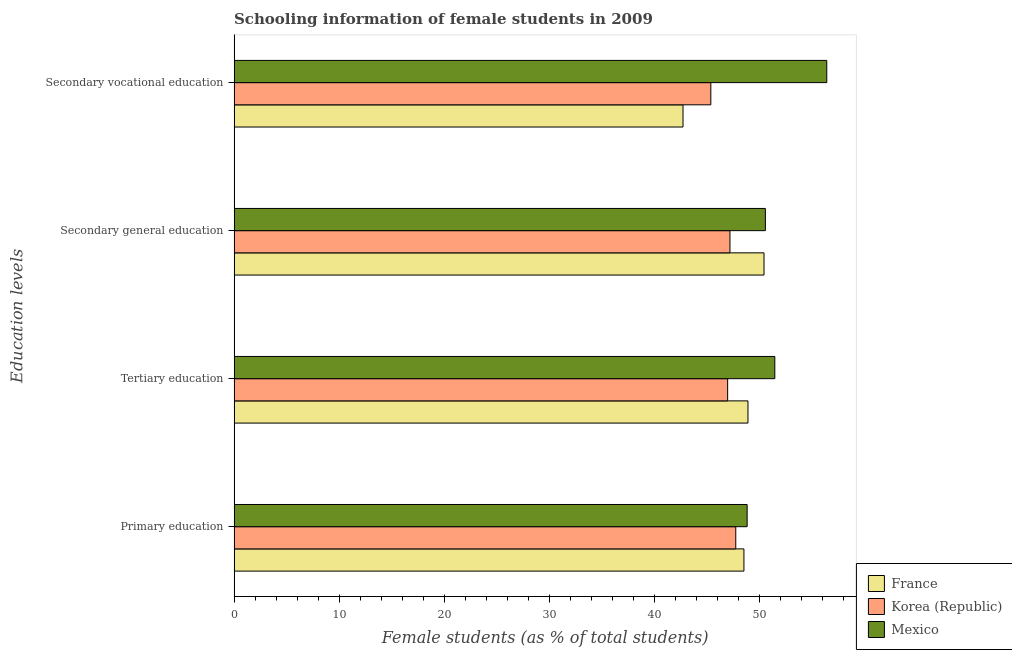How many different coloured bars are there?
Your response must be concise. 3. Are the number of bars per tick equal to the number of legend labels?
Ensure brevity in your answer.  Yes. Are the number of bars on each tick of the Y-axis equal?
Your response must be concise. Yes. How many bars are there on the 2nd tick from the bottom?
Give a very brief answer. 3. What is the label of the 2nd group of bars from the top?
Offer a very short reply. Secondary general education. What is the percentage of female students in tertiary education in France?
Your answer should be very brief. 48.91. Across all countries, what is the maximum percentage of female students in tertiary education?
Keep it short and to the point. 51.46. Across all countries, what is the minimum percentage of female students in secondary education?
Provide a short and direct response. 47.2. What is the total percentage of female students in secondary education in the graph?
Offer a very short reply. 148.2. What is the difference between the percentage of female students in secondary vocational education in France and that in Korea (Republic)?
Make the answer very short. -2.65. What is the difference between the percentage of female students in tertiary education in Korea (Republic) and the percentage of female students in primary education in France?
Your response must be concise. -1.55. What is the average percentage of female students in secondary education per country?
Give a very brief answer. 49.4. What is the difference between the percentage of female students in secondary vocational education and percentage of female students in primary education in Mexico?
Provide a succinct answer. 7.58. What is the ratio of the percentage of female students in tertiary education in Korea (Republic) to that in France?
Your response must be concise. 0.96. What is the difference between the highest and the second highest percentage of female students in secondary education?
Your answer should be very brief. 0.13. What is the difference between the highest and the lowest percentage of female students in secondary vocational education?
Provide a short and direct response. 13.68. In how many countries, is the percentage of female students in secondary vocational education greater than the average percentage of female students in secondary vocational education taken over all countries?
Offer a very short reply. 1. Is it the case that in every country, the sum of the percentage of female students in primary education and percentage of female students in tertiary education is greater than the sum of percentage of female students in secondary vocational education and percentage of female students in secondary education?
Your answer should be compact. No. What does the 3rd bar from the top in Primary education represents?
Make the answer very short. France. What does the 3rd bar from the bottom in Primary education represents?
Give a very brief answer. Mexico. Is it the case that in every country, the sum of the percentage of female students in primary education and percentage of female students in tertiary education is greater than the percentage of female students in secondary education?
Keep it short and to the point. Yes. How many bars are there?
Your answer should be compact. 12. What is the difference between two consecutive major ticks on the X-axis?
Give a very brief answer. 10. Are the values on the major ticks of X-axis written in scientific E-notation?
Your answer should be very brief. No. Does the graph contain grids?
Your response must be concise. No. Where does the legend appear in the graph?
Your response must be concise. Bottom right. How are the legend labels stacked?
Offer a terse response. Vertical. What is the title of the graph?
Ensure brevity in your answer.  Schooling information of female students in 2009. What is the label or title of the X-axis?
Your answer should be compact. Female students (as % of total students). What is the label or title of the Y-axis?
Provide a succinct answer. Education levels. What is the Female students (as % of total students) in France in Primary education?
Keep it short and to the point. 48.53. What is the Female students (as % of total students) of Korea (Republic) in Primary education?
Give a very brief answer. 47.75. What is the Female students (as % of total students) of Mexico in Primary education?
Your answer should be very brief. 48.83. What is the Female students (as % of total students) of France in Tertiary education?
Offer a terse response. 48.91. What is the Female students (as % of total students) of Korea (Republic) in Tertiary education?
Ensure brevity in your answer.  46.98. What is the Female students (as % of total students) in Mexico in Tertiary education?
Keep it short and to the point. 51.46. What is the Female students (as % of total students) of France in Secondary general education?
Your response must be concise. 50.44. What is the Female students (as % of total students) of Korea (Republic) in Secondary general education?
Your answer should be compact. 47.2. What is the Female students (as % of total students) in Mexico in Secondary general education?
Keep it short and to the point. 50.57. What is the Female students (as % of total students) in France in Secondary vocational education?
Your answer should be compact. 42.73. What is the Female students (as % of total students) in Korea (Republic) in Secondary vocational education?
Keep it short and to the point. 45.38. What is the Female students (as % of total students) of Mexico in Secondary vocational education?
Make the answer very short. 56.41. Across all Education levels, what is the maximum Female students (as % of total students) of France?
Provide a short and direct response. 50.44. Across all Education levels, what is the maximum Female students (as % of total students) of Korea (Republic)?
Provide a succinct answer. 47.75. Across all Education levels, what is the maximum Female students (as % of total students) in Mexico?
Ensure brevity in your answer.  56.41. Across all Education levels, what is the minimum Female students (as % of total students) in France?
Ensure brevity in your answer.  42.73. Across all Education levels, what is the minimum Female students (as % of total students) in Korea (Republic)?
Provide a succinct answer. 45.38. Across all Education levels, what is the minimum Female students (as % of total students) in Mexico?
Keep it short and to the point. 48.83. What is the total Female students (as % of total students) in France in the graph?
Provide a short and direct response. 190.6. What is the total Female students (as % of total students) in Korea (Republic) in the graph?
Offer a terse response. 187.3. What is the total Female students (as % of total students) in Mexico in the graph?
Give a very brief answer. 207.27. What is the difference between the Female students (as % of total students) in France in Primary education and that in Tertiary education?
Provide a short and direct response. -0.38. What is the difference between the Female students (as % of total students) in Korea (Republic) in Primary education and that in Tertiary education?
Your answer should be compact. 0.77. What is the difference between the Female students (as % of total students) in Mexico in Primary education and that in Tertiary education?
Offer a very short reply. -2.63. What is the difference between the Female students (as % of total students) of France in Primary education and that in Secondary general education?
Your answer should be very brief. -1.91. What is the difference between the Female students (as % of total students) in Korea (Republic) in Primary education and that in Secondary general education?
Make the answer very short. 0.55. What is the difference between the Female students (as % of total students) of Mexico in Primary education and that in Secondary general education?
Ensure brevity in your answer.  -1.73. What is the difference between the Female students (as % of total students) in France in Primary education and that in Secondary vocational education?
Ensure brevity in your answer.  5.8. What is the difference between the Female students (as % of total students) of Korea (Republic) in Primary education and that in Secondary vocational education?
Provide a short and direct response. 2.37. What is the difference between the Female students (as % of total students) of Mexico in Primary education and that in Secondary vocational education?
Provide a short and direct response. -7.58. What is the difference between the Female students (as % of total students) of France in Tertiary education and that in Secondary general education?
Offer a very short reply. -1.53. What is the difference between the Female students (as % of total students) in Korea (Republic) in Tertiary education and that in Secondary general education?
Your answer should be compact. -0.22. What is the difference between the Female students (as % of total students) in Mexico in Tertiary education and that in Secondary general education?
Provide a short and direct response. 0.9. What is the difference between the Female students (as % of total students) in France in Tertiary education and that in Secondary vocational education?
Your response must be concise. 6.18. What is the difference between the Female students (as % of total students) of Mexico in Tertiary education and that in Secondary vocational education?
Provide a succinct answer. -4.95. What is the difference between the Female students (as % of total students) of France in Secondary general education and that in Secondary vocational education?
Provide a succinct answer. 7.71. What is the difference between the Female students (as % of total students) in Korea (Republic) in Secondary general education and that in Secondary vocational education?
Keep it short and to the point. 1.82. What is the difference between the Female students (as % of total students) in Mexico in Secondary general education and that in Secondary vocational education?
Your response must be concise. -5.84. What is the difference between the Female students (as % of total students) of France in Primary education and the Female students (as % of total students) of Korea (Republic) in Tertiary education?
Give a very brief answer. 1.55. What is the difference between the Female students (as % of total students) of France in Primary education and the Female students (as % of total students) of Mexico in Tertiary education?
Your answer should be very brief. -2.94. What is the difference between the Female students (as % of total students) of Korea (Republic) in Primary education and the Female students (as % of total students) of Mexico in Tertiary education?
Your answer should be very brief. -3.72. What is the difference between the Female students (as % of total students) in France in Primary education and the Female students (as % of total students) in Korea (Republic) in Secondary general education?
Ensure brevity in your answer.  1.33. What is the difference between the Female students (as % of total students) in France in Primary education and the Female students (as % of total students) in Mexico in Secondary general education?
Your answer should be compact. -2.04. What is the difference between the Female students (as % of total students) of Korea (Republic) in Primary education and the Female students (as % of total students) of Mexico in Secondary general education?
Keep it short and to the point. -2.82. What is the difference between the Female students (as % of total students) of France in Primary education and the Female students (as % of total students) of Korea (Republic) in Secondary vocational education?
Offer a terse response. 3.15. What is the difference between the Female students (as % of total students) of France in Primary education and the Female students (as % of total students) of Mexico in Secondary vocational education?
Keep it short and to the point. -7.88. What is the difference between the Female students (as % of total students) in Korea (Republic) in Primary education and the Female students (as % of total students) in Mexico in Secondary vocational education?
Ensure brevity in your answer.  -8.66. What is the difference between the Female students (as % of total students) of France in Tertiary education and the Female students (as % of total students) of Korea (Republic) in Secondary general education?
Provide a succinct answer. 1.71. What is the difference between the Female students (as % of total students) in France in Tertiary education and the Female students (as % of total students) in Mexico in Secondary general education?
Your answer should be compact. -1.66. What is the difference between the Female students (as % of total students) of Korea (Republic) in Tertiary education and the Female students (as % of total students) of Mexico in Secondary general education?
Your answer should be compact. -3.59. What is the difference between the Female students (as % of total students) in France in Tertiary education and the Female students (as % of total students) in Korea (Republic) in Secondary vocational education?
Offer a very short reply. 3.53. What is the difference between the Female students (as % of total students) of France in Tertiary education and the Female students (as % of total students) of Mexico in Secondary vocational education?
Offer a very short reply. -7.5. What is the difference between the Female students (as % of total students) in Korea (Republic) in Tertiary education and the Female students (as % of total students) in Mexico in Secondary vocational education?
Provide a succinct answer. -9.43. What is the difference between the Female students (as % of total students) in France in Secondary general education and the Female students (as % of total students) in Korea (Republic) in Secondary vocational education?
Offer a very short reply. 5.06. What is the difference between the Female students (as % of total students) of France in Secondary general education and the Female students (as % of total students) of Mexico in Secondary vocational education?
Ensure brevity in your answer.  -5.97. What is the difference between the Female students (as % of total students) of Korea (Republic) in Secondary general education and the Female students (as % of total students) of Mexico in Secondary vocational education?
Offer a very short reply. -9.22. What is the average Female students (as % of total students) of France per Education levels?
Offer a very short reply. 47.65. What is the average Female students (as % of total students) in Korea (Republic) per Education levels?
Your answer should be compact. 46.82. What is the average Female students (as % of total students) in Mexico per Education levels?
Offer a terse response. 51.82. What is the difference between the Female students (as % of total students) of France and Female students (as % of total students) of Korea (Republic) in Primary education?
Your answer should be very brief. 0.78. What is the difference between the Female students (as % of total students) in France and Female students (as % of total students) in Mexico in Primary education?
Your response must be concise. -0.31. What is the difference between the Female students (as % of total students) of Korea (Republic) and Female students (as % of total students) of Mexico in Primary education?
Keep it short and to the point. -1.08. What is the difference between the Female students (as % of total students) of France and Female students (as % of total students) of Korea (Republic) in Tertiary education?
Offer a very short reply. 1.93. What is the difference between the Female students (as % of total students) in France and Female students (as % of total students) in Mexico in Tertiary education?
Provide a short and direct response. -2.55. What is the difference between the Female students (as % of total students) of Korea (Republic) and Female students (as % of total students) of Mexico in Tertiary education?
Your answer should be compact. -4.49. What is the difference between the Female students (as % of total students) in France and Female students (as % of total students) in Korea (Republic) in Secondary general education?
Give a very brief answer. 3.24. What is the difference between the Female students (as % of total students) of France and Female students (as % of total students) of Mexico in Secondary general education?
Your answer should be compact. -0.13. What is the difference between the Female students (as % of total students) in Korea (Republic) and Female students (as % of total students) in Mexico in Secondary general education?
Ensure brevity in your answer.  -3.37. What is the difference between the Female students (as % of total students) in France and Female students (as % of total students) in Korea (Republic) in Secondary vocational education?
Keep it short and to the point. -2.65. What is the difference between the Female students (as % of total students) of France and Female students (as % of total students) of Mexico in Secondary vocational education?
Provide a succinct answer. -13.68. What is the difference between the Female students (as % of total students) in Korea (Republic) and Female students (as % of total students) in Mexico in Secondary vocational education?
Keep it short and to the point. -11.03. What is the ratio of the Female students (as % of total students) of Korea (Republic) in Primary education to that in Tertiary education?
Your response must be concise. 1.02. What is the ratio of the Female students (as % of total students) in Mexico in Primary education to that in Tertiary education?
Keep it short and to the point. 0.95. What is the ratio of the Female students (as % of total students) of France in Primary education to that in Secondary general education?
Your answer should be compact. 0.96. What is the ratio of the Female students (as % of total students) in Korea (Republic) in Primary education to that in Secondary general education?
Provide a short and direct response. 1.01. What is the ratio of the Female students (as % of total students) of Mexico in Primary education to that in Secondary general education?
Your answer should be compact. 0.97. What is the ratio of the Female students (as % of total students) in France in Primary education to that in Secondary vocational education?
Ensure brevity in your answer.  1.14. What is the ratio of the Female students (as % of total students) of Korea (Republic) in Primary education to that in Secondary vocational education?
Offer a very short reply. 1.05. What is the ratio of the Female students (as % of total students) of Mexico in Primary education to that in Secondary vocational education?
Provide a short and direct response. 0.87. What is the ratio of the Female students (as % of total students) in France in Tertiary education to that in Secondary general education?
Give a very brief answer. 0.97. What is the ratio of the Female students (as % of total students) of Korea (Republic) in Tertiary education to that in Secondary general education?
Your answer should be compact. 1. What is the ratio of the Female students (as % of total students) in Mexico in Tertiary education to that in Secondary general education?
Offer a terse response. 1.02. What is the ratio of the Female students (as % of total students) in France in Tertiary education to that in Secondary vocational education?
Give a very brief answer. 1.14. What is the ratio of the Female students (as % of total students) of Korea (Republic) in Tertiary education to that in Secondary vocational education?
Provide a short and direct response. 1.04. What is the ratio of the Female students (as % of total students) of Mexico in Tertiary education to that in Secondary vocational education?
Offer a very short reply. 0.91. What is the ratio of the Female students (as % of total students) of France in Secondary general education to that in Secondary vocational education?
Provide a short and direct response. 1.18. What is the ratio of the Female students (as % of total students) of Korea (Republic) in Secondary general education to that in Secondary vocational education?
Ensure brevity in your answer.  1.04. What is the ratio of the Female students (as % of total students) in Mexico in Secondary general education to that in Secondary vocational education?
Keep it short and to the point. 0.9. What is the difference between the highest and the second highest Female students (as % of total students) in France?
Your answer should be compact. 1.53. What is the difference between the highest and the second highest Female students (as % of total students) in Korea (Republic)?
Your answer should be very brief. 0.55. What is the difference between the highest and the second highest Female students (as % of total students) of Mexico?
Make the answer very short. 4.95. What is the difference between the highest and the lowest Female students (as % of total students) in France?
Make the answer very short. 7.71. What is the difference between the highest and the lowest Female students (as % of total students) of Korea (Republic)?
Offer a terse response. 2.37. What is the difference between the highest and the lowest Female students (as % of total students) of Mexico?
Make the answer very short. 7.58. 